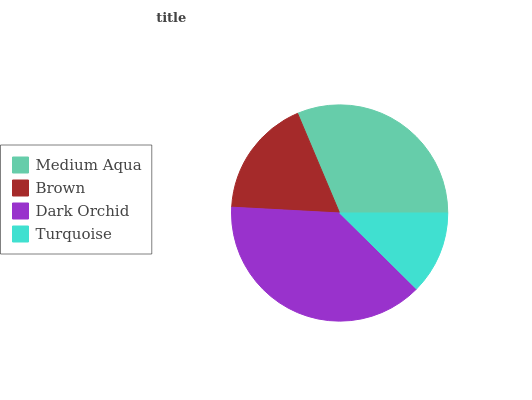Is Turquoise the minimum?
Answer yes or no. Yes. Is Dark Orchid the maximum?
Answer yes or no. Yes. Is Brown the minimum?
Answer yes or no. No. Is Brown the maximum?
Answer yes or no. No. Is Medium Aqua greater than Brown?
Answer yes or no. Yes. Is Brown less than Medium Aqua?
Answer yes or no. Yes. Is Brown greater than Medium Aqua?
Answer yes or no. No. Is Medium Aqua less than Brown?
Answer yes or no. No. Is Medium Aqua the high median?
Answer yes or no. Yes. Is Brown the low median?
Answer yes or no. Yes. Is Dark Orchid the high median?
Answer yes or no. No. Is Medium Aqua the low median?
Answer yes or no. No. 